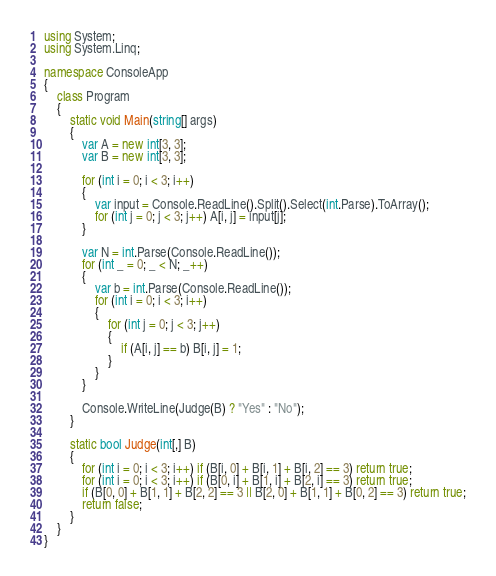<code> <loc_0><loc_0><loc_500><loc_500><_C#_>using System;
using System.Linq;

namespace ConsoleApp
{
    class Program
    {
        static void Main(string[] args)
        {
            var A = new int[3, 3];
            var B = new int[3, 3];

            for (int i = 0; i < 3; i++)
            {
                var input = Console.ReadLine().Split().Select(int.Parse).ToArray();
                for (int j = 0; j < 3; j++) A[i, j] = input[j];
            }

            var N = int.Parse(Console.ReadLine());
            for (int _ = 0; _ < N; _++)
            {
                var b = int.Parse(Console.ReadLine());
                for (int i = 0; i < 3; i++)
                {
                    for (int j = 0; j < 3; j++)
                    {
                        if (A[i, j] == b) B[i, j] = 1;
                    }
                }
            }

            Console.WriteLine(Judge(B) ? "Yes" : "No");
        }

        static bool Judge(int[,] B)
        {
            for (int i = 0; i < 3; i++) if (B[i, 0] + B[i, 1] + B[i, 2] == 3) return true;
            for (int i = 0; i < 3; i++) if (B[0, i] + B[1, i] + B[2, i] == 3) return true;
            if (B[0, 0] + B[1, 1] + B[2, 2] == 3 || B[2, 0] + B[1, 1] + B[0, 2] == 3) return true;
            return false;
        }
    }
}
</code> 